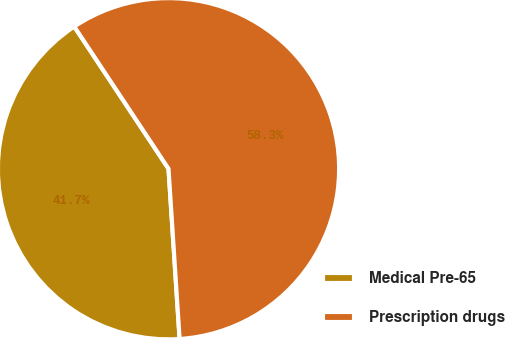<chart> <loc_0><loc_0><loc_500><loc_500><pie_chart><fcel>Medical Pre-65<fcel>Prescription drugs<nl><fcel>41.72%<fcel>58.28%<nl></chart> 